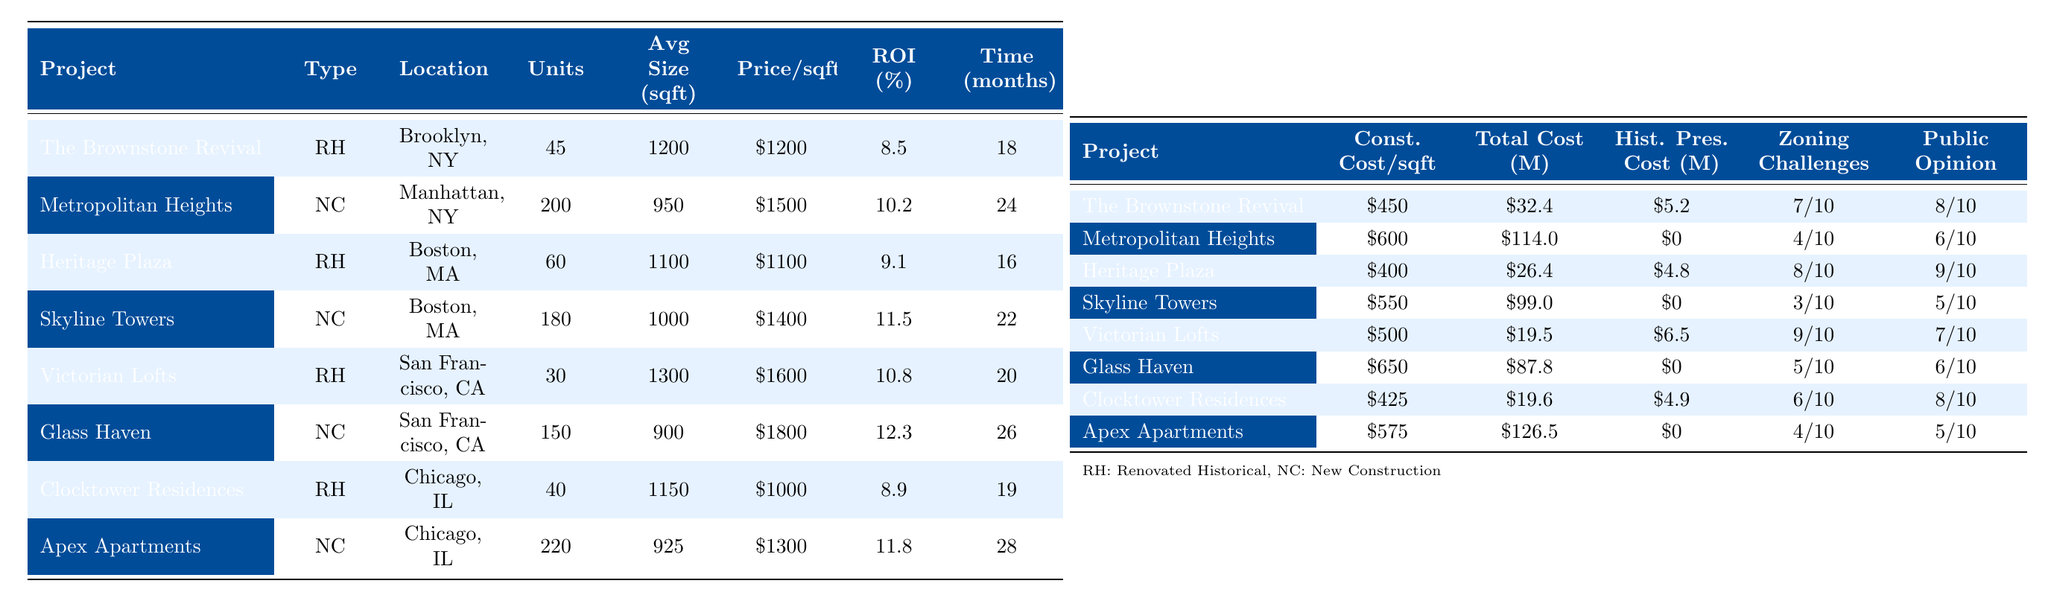What is the expected annual ROI percentage for Skyline Towers? The expected annual ROI percentage for Skyline Towers is listed in the table as 11.5%.
Answer: 11.5% Which project has the highest average price per square foot? The table shows that Glass Haven has the highest average price per square foot at $1,800.
Answer: Glass Haven How many total units are in the renovated historical projects combined? The total units for the renovated historical projects are: 45 (The Brownstone Revival) + 60 (Heritage Plaza) + 30 (Victorian Lofts) + 40 (Clocktower Residences) = 175.
Answer: 175 Which new construction project has the shortest time to completion? Among new construction projects, Metropolitan Heights takes 24 months, Skyline Towers takes 22 months, Glass Haven takes 26 months, and Apex Apartments takes 28 months. Thus, Skyline Towers has the shortest time at 22 months.
Answer: Skyline Towers What is the total development cost for the Victorian Lofts? The total development cost for Victorian Lofts is $19.5 million, as shown in the table.
Answer: $19.5 million Is there a historical preservation cost associated with the Metropolitan Heights project? The table indicates that there is no historical preservation cost for Metropolitan Heights, as its cost is listed as $0.
Answer: No What is the average construction cost per square foot for all new construction projects? The construction cost per square foot for new constructions is: $600 (Metropolitan Heights) + $550 (Skyline Towers) + $650 (Glass Haven) + $575 (Apex Apartments) = $2,375. Dividing this by 4 projects gives an average of 2,375/4 = $593.75.
Answer: $593.75 Which type of building generally shows a higher expected ROI, renovated historical buildings or newly constructed ones? Looking at the expected ROI percentages: Renovated historical projects have 8.5%, 9.1%, 10.8%, 8.9%, averaging 9.3%. New constructions have 10.2%, 11.5%, 12.3%, 11.8%, averaging 11.5%. Since 11.5% (new) is greater than 9.3% (historical), new constructions show a higher expected ROI.
Answer: Newly constructed buildings How many more units does Apex Apartments have compared to Clocktower Residences? Apex Apartments has 220 units while Clocktower Residences has 40 units. The difference is 220 - 40 = 180 more units.
Answer: 180 more units What is the public opinion score for the Glass Haven project? The public opinion score for Glass Haven is listed in the table as 6 out of 10.
Answer: 6/10 